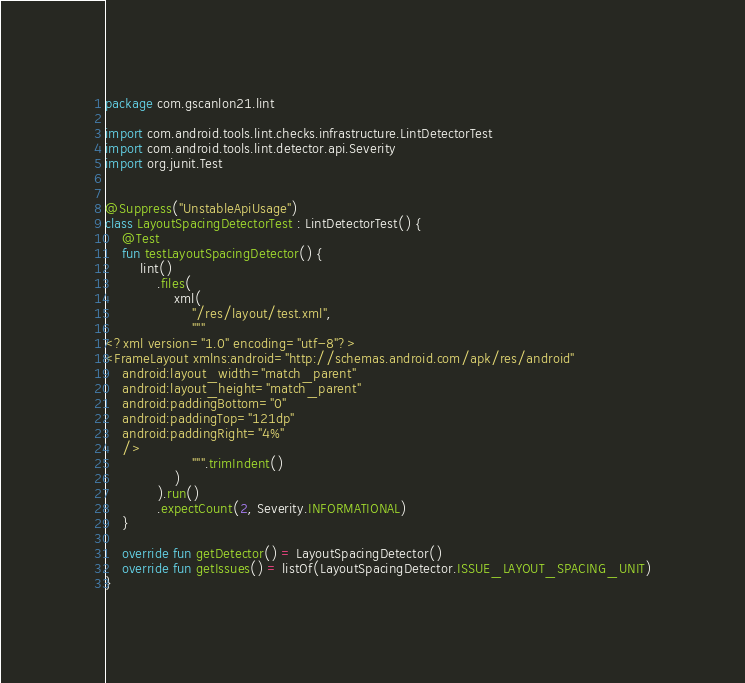<code> <loc_0><loc_0><loc_500><loc_500><_Kotlin_>package com.gscanlon21.lint

import com.android.tools.lint.checks.infrastructure.LintDetectorTest
import com.android.tools.lint.detector.api.Severity
import org.junit.Test


@Suppress("UnstableApiUsage")
class LayoutSpacingDetectorTest : LintDetectorTest() {
    @Test
    fun testLayoutSpacingDetector() {
        lint()
            .files(
                xml(
                    "/res/layout/test.xml",
                    """
<?xml version="1.0" encoding="utf-8"?>
<FrameLayout xmlns:android="http://schemas.android.com/apk/res/android"
    android:layout_width="match_parent"
    android:layout_height="match_parent"
    android:paddingBottom="0"
    android:paddingTop="121dp"
    android:paddingRight="4%"
    />
                    """.trimIndent()
                )
            ).run()
            .expectCount(2, Severity.INFORMATIONAL)
    }

    override fun getDetector() = LayoutSpacingDetector()
    override fun getIssues() = listOf(LayoutSpacingDetector.ISSUE_LAYOUT_SPACING_UNIT)
}</code> 